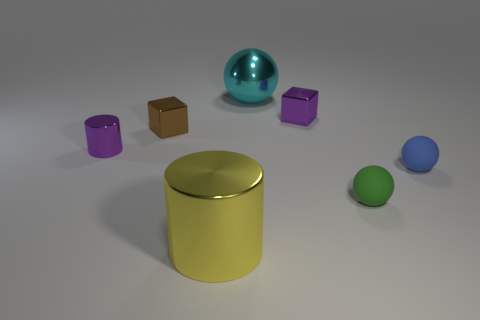Add 2 big gray rubber spheres. How many objects exist? 9 Subtract all cubes. How many objects are left? 5 Subtract all cyan objects. Subtract all purple metal cubes. How many objects are left? 5 Add 1 cubes. How many cubes are left? 3 Add 6 small metallic blocks. How many small metallic blocks exist? 8 Subtract 0 green cylinders. How many objects are left? 7 